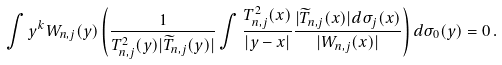<formula> <loc_0><loc_0><loc_500><loc_500>\int y ^ { k } W _ { { n } , j } ( y ) \left ( \frac { 1 } { T _ { { n } , j } ^ { 2 } ( y ) | \widetilde { T } _ { { n } , j } ( y ) | } \int \frac { T _ { { n } , j } ^ { 2 } ( x ) } { | y - x | } \frac { | \widetilde { T } _ { { n } , j } ( x ) | d \sigma _ { j } ( x ) } { | W _ { { n } , j } ( x ) | } \right ) d \sigma _ { 0 } ( y ) = 0 \, .</formula> 